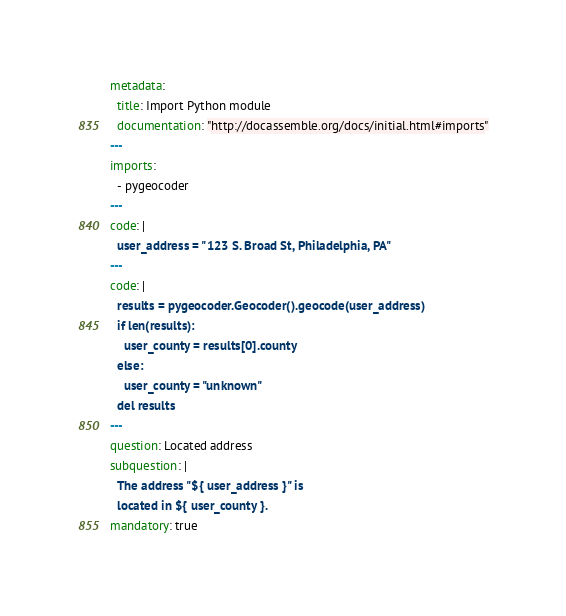Convert code to text. <code><loc_0><loc_0><loc_500><loc_500><_YAML_>metadata:
  title: Import Python module
  documentation: "http://docassemble.org/docs/initial.html#imports"
---
imports:
  - pygeocoder
---
code: |
  user_address = "123 S. Broad St, Philadelphia, PA"
---
code: |
  results = pygeocoder.Geocoder().geocode(user_address)
  if len(results):
    user_county = results[0].county
  else:
    user_county = "unknown"
  del results
---
question: Located address
subquestion: |
  The address "${ user_address }" is
  located in ${ user_county }.
mandatory: true
</code> 